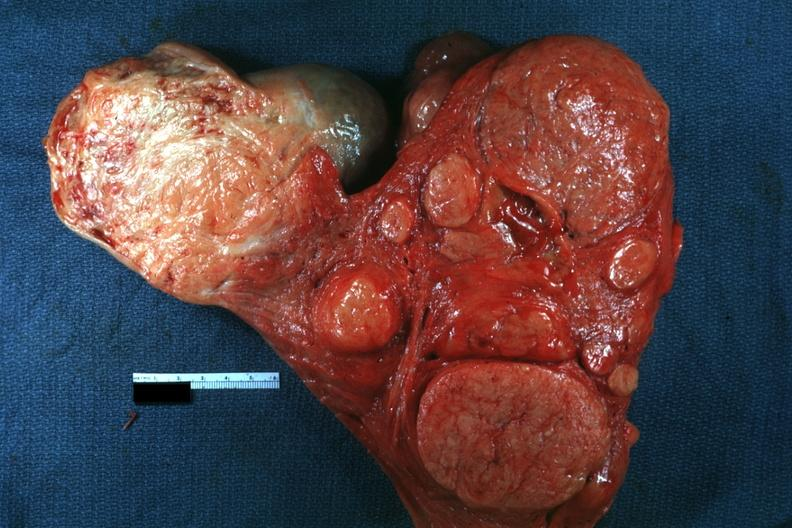s benign cystic teratoma present?
Answer the question using a single word or phrase. No 